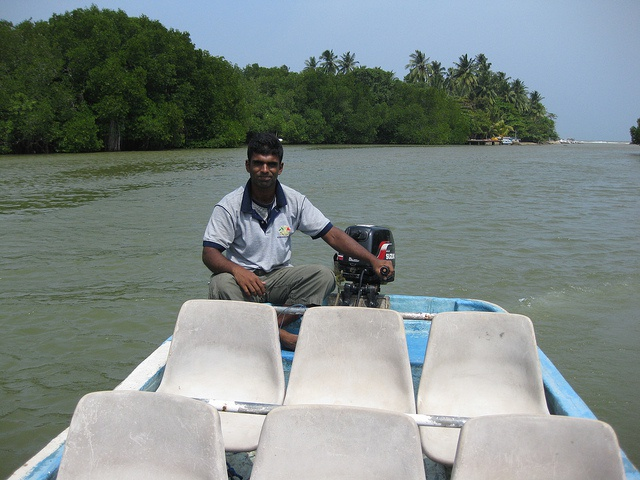Describe the objects in this image and their specific colors. I can see boat in gray, lightgray, and darkgray tones, people in gray, black, and darkgray tones, chair in gray, lightgray, and darkgray tones, chair in gray, lightgray, and darkgray tones, and chair in gray, lightgray, and darkgray tones in this image. 